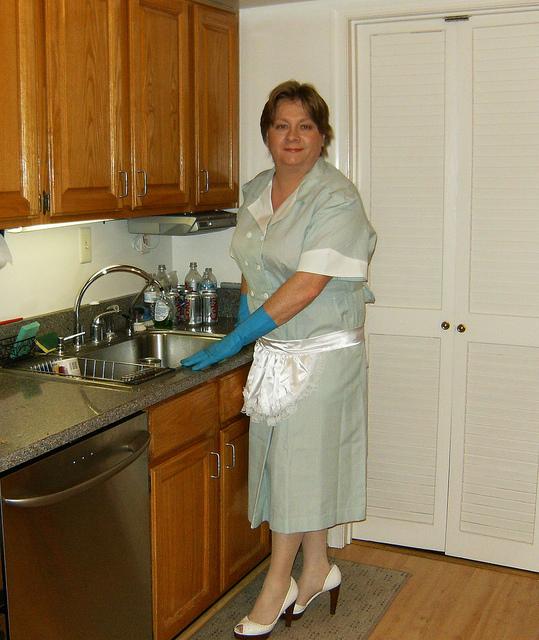Did the lady use gloves to wash dishes?
Answer briefly. Yes. Is the woman a nurse?
Be succinct. No. What is the sink made out of?
Quick response, please. Metal. 